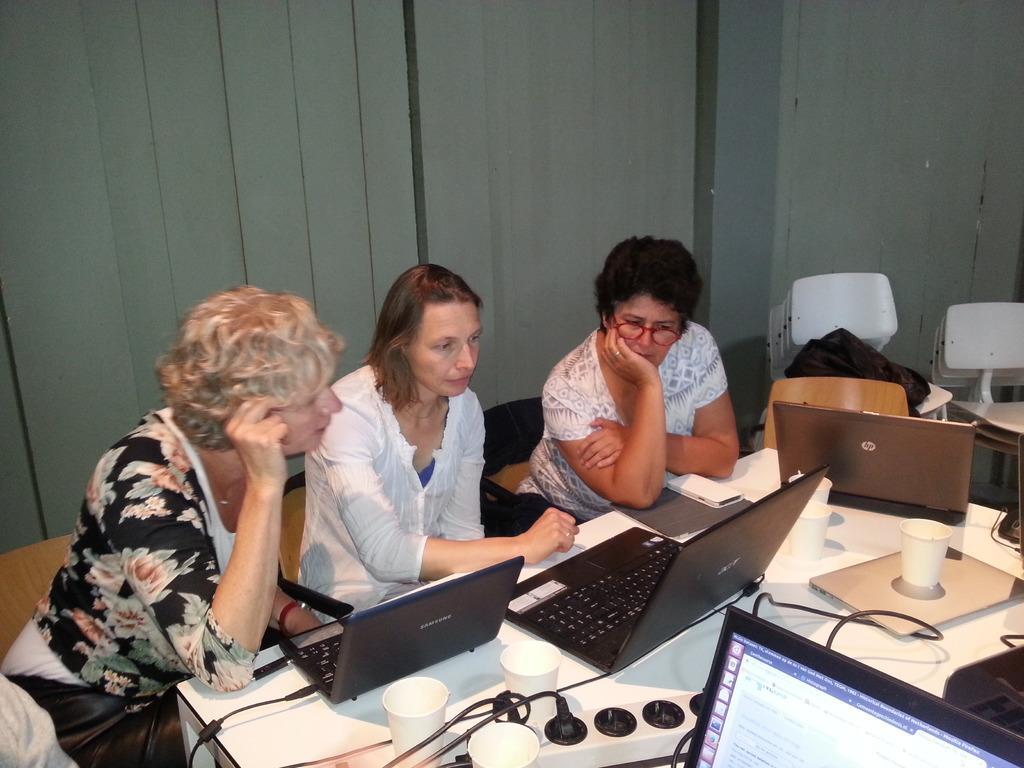Can you describe this image briefly? This picture shows three women seated and working on their laptops. 